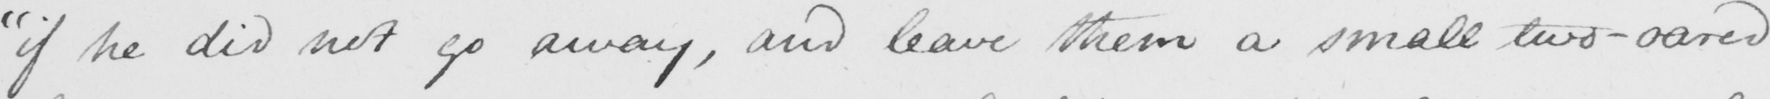What is written in this line of handwriting? " if he did not go away , and leave them a small two-oared 